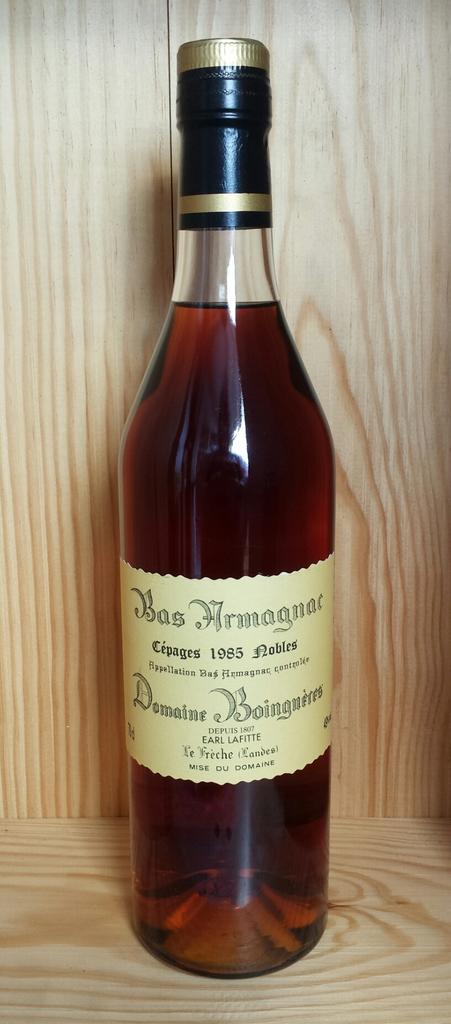What year is the drink from?
Give a very brief answer. 1985. What year is on the bottle?
Give a very brief answer. 1985. 